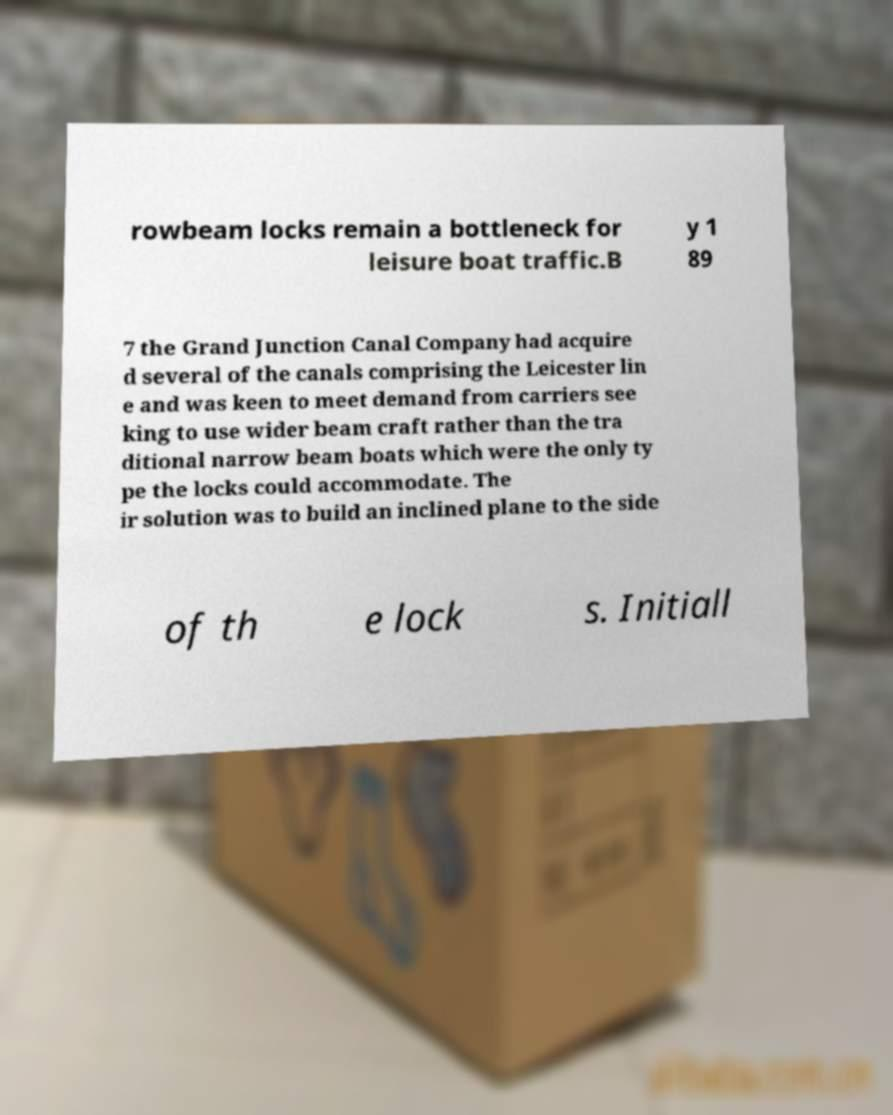Please identify and transcribe the text found in this image. rowbeam locks remain a bottleneck for leisure boat traffic.B y 1 89 7 the Grand Junction Canal Company had acquire d several of the canals comprising the Leicester lin e and was keen to meet demand from carriers see king to use wider beam craft rather than the tra ditional narrow beam boats which were the only ty pe the locks could accommodate. The ir solution was to build an inclined plane to the side of th e lock s. Initiall 